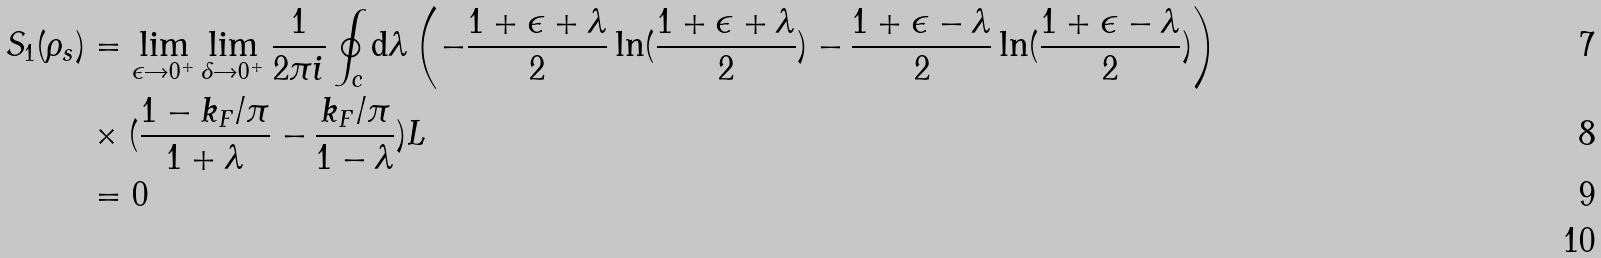<formula> <loc_0><loc_0><loc_500><loc_500>S _ { 1 } ( \rho _ { s } ) & = \lim _ { \epsilon \rightarrow 0 ^ { + } } \lim _ { \delta \rightarrow 0 ^ { + } } \frac { 1 } { 2 \pi i } \oint _ { c } \text {d} \lambda \left ( - \frac { 1 + \epsilon + \lambda } { 2 } \ln ( \frac { 1 + \epsilon + \lambda } { 2 } ) - \frac { 1 + \epsilon - \lambda } { 2 } \ln ( \frac { 1 + \epsilon - \lambda } { 2 } ) \right ) \\ & \times ( \frac { 1 - k _ { F } / \pi } { 1 + \lambda } - \frac { k _ { F } / \pi } { 1 - \lambda } ) L \\ & = 0 \\</formula> 